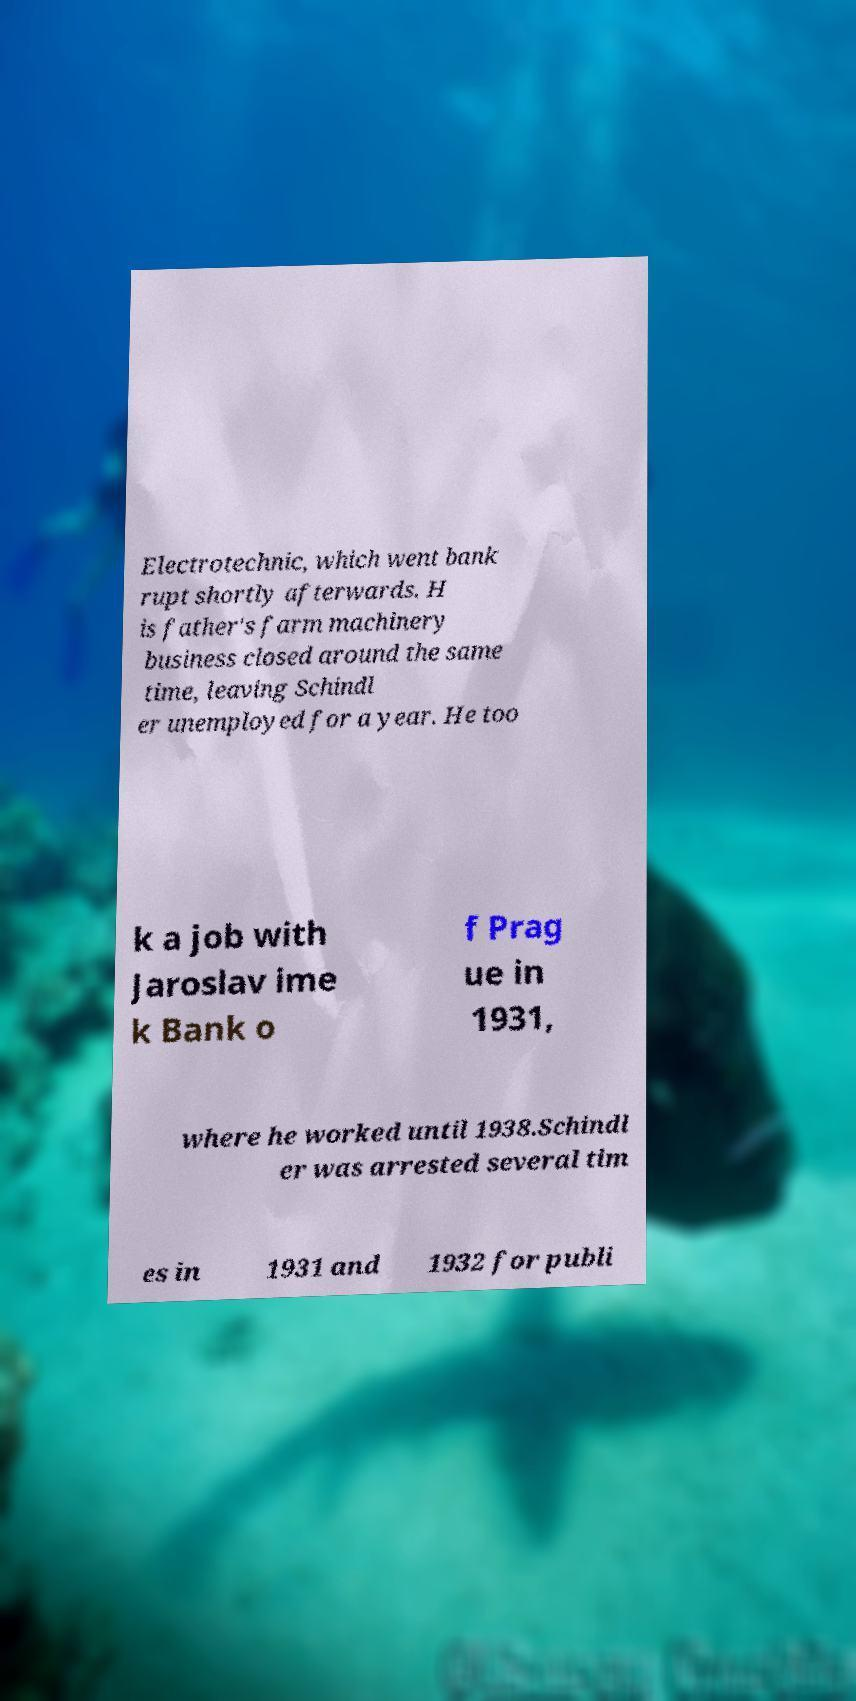For documentation purposes, I need the text within this image transcribed. Could you provide that? Electrotechnic, which went bank rupt shortly afterwards. H is father's farm machinery business closed around the same time, leaving Schindl er unemployed for a year. He too k a job with Jaroslav ime k Bank o f Prag ue in 1931, where he worked until 1938.Schindl er was arrested several tim es in 1931 and 1932 for publi 